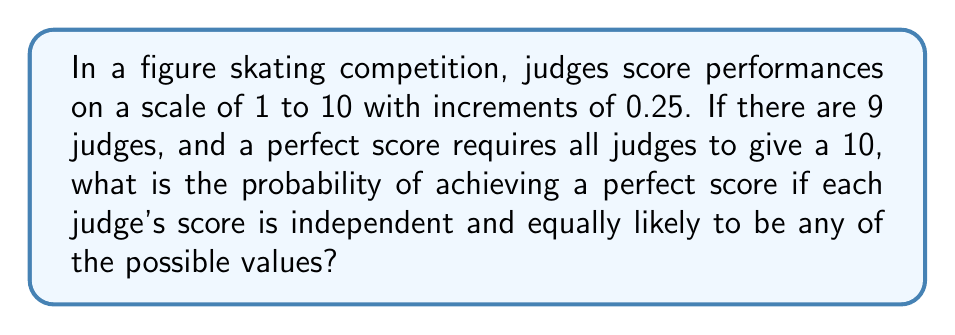What is the answer to this math problem? Let's approach this step-by-step:

1) First, we need to determine how many possible scores each judge can give:
   From 1 to 10 with increments of 0.25, we have:
   $$(10 - 1) / 0.25 + 1 = 37$$ possible scores

2) For a perfect score, all 9 judges must give a 10. This is just one specific outcome out of all possible outcomes.

3) The probability of one judge giving a 10 is:
   $$P(\text{judge gives 10}) = \frac{1}{37}$$

4) Since each judge's score is independent, we can use the multiplication rule of probability. The probability of all 9 judges giving a 10 is:
   $$P(\text{all 9 judges give 10}) = \left(\frac{1}{37}\right)^9$$

5) Let's calculate this:
   $$\left(\frac{1}{37}\right)^9 = \frac{1}{37^9} = \frac{1}{25,144,747,810,491} \approx 3.977 \times 10^{-11}$$
Answer: $\frac{1}{37^9}$ or approximately $3.977 \times 10^{-11}$ 